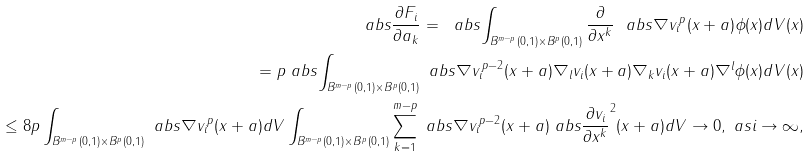<formula> <loc_0><loc_0><loc_500><loc_500>\ a b s { \frac { \partial F _ { i } } { \partial a _ { k } } } = \ a b s { \int _ { B ^ { m - p } ( 0 , 1 ) \times B ^ { p } ( 0 , 1 ) } \frac { \partial } { \partial x ^ { k } } \ a b s { \nabla v _ { i } } ^ { p } ( x + a ) \phi ( x ) d V ( x ) } \\ = p \ a b s { \int _ { B ^ { m - p } ( 0 , 1 ) \times B ^ { p } ( 0 , 1 ) } \ a b s { \nabla v _ { i } } ^ { p - 2 } ( x + a ) \nabla _ { l } v _ { i } ( x + a ) \nabla _ { k } v _ { i } ( x + a ) \nabla ^ { l } \phi ( x ) d V ( x ) } \\ \leq 8 p \int _ { B ^ { m - p } ( 0 , 1 ) \times B ^ { p } ( 0 , 1 ) } \ a b s { \nabla v _ { i } } ^ { p } ( x + a ) d V \int _ { B ^ { m - p } ( 0 , 1 ) \times B ^ { p } ( 0 , 1 ) } \sum _ { k = 1 } ^ { m - p } \ a b s { \nabla v _ { i } } ^ { p - 2 } ( x + a ) \ a b s { \frac { \partial v _ { i } } { \partial x ^ { k } } } ^ { 2 } ( x + a ) d V \to 0 , \ a s i \to \infty ,</formula> 